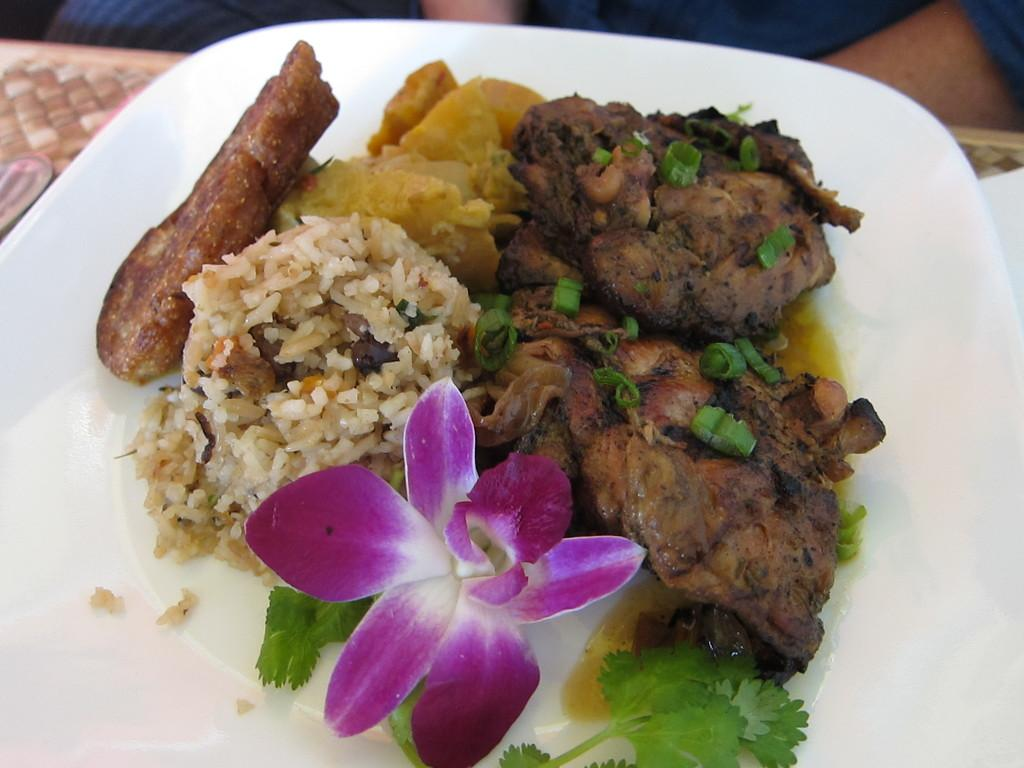What is on the plate that is visible in the image? There is a plate with food in the image. What other item can be seen in the image besides the plate of food? There is a flower in the image. What is the location of the objects in the image? The objects are on the table in the image. Whose hands are visible in the image? A person's hands are visible in the image. What type of acoustics can be heard in the image? There is no audible sound in the image, so it is not possible to determine the acoustics. 